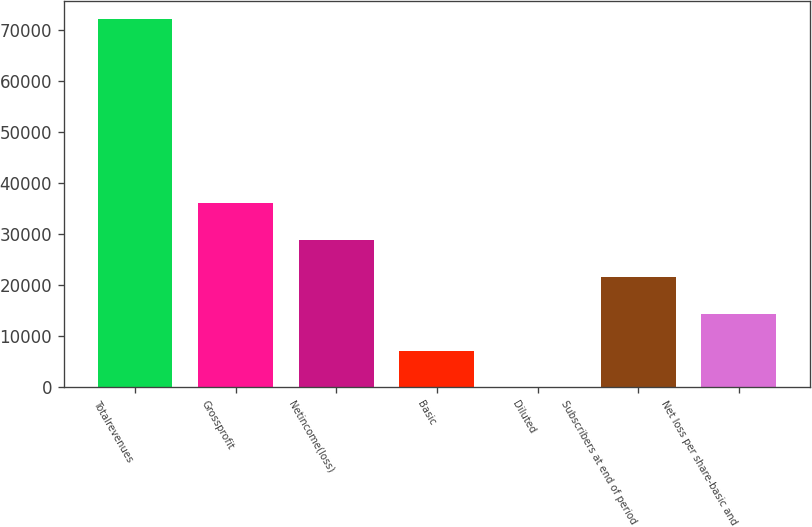<chart> <loc_0><loc_0><loc_500><loc_500><bar_chart><fcel>Totalrevenues<fcel>Grossprofit<fcel>Netincome(loss)<fcel>Basic<fcel>Diluted<fcel>Subscribers at end of period<fcel>Net loss per share-basic and<nl><fcel>72202<fcel>36101<fcel>28880.8<fcel>7220.24<fcel>0.05<fcel>21660.6<fcel>14440.4<nl></chart> 